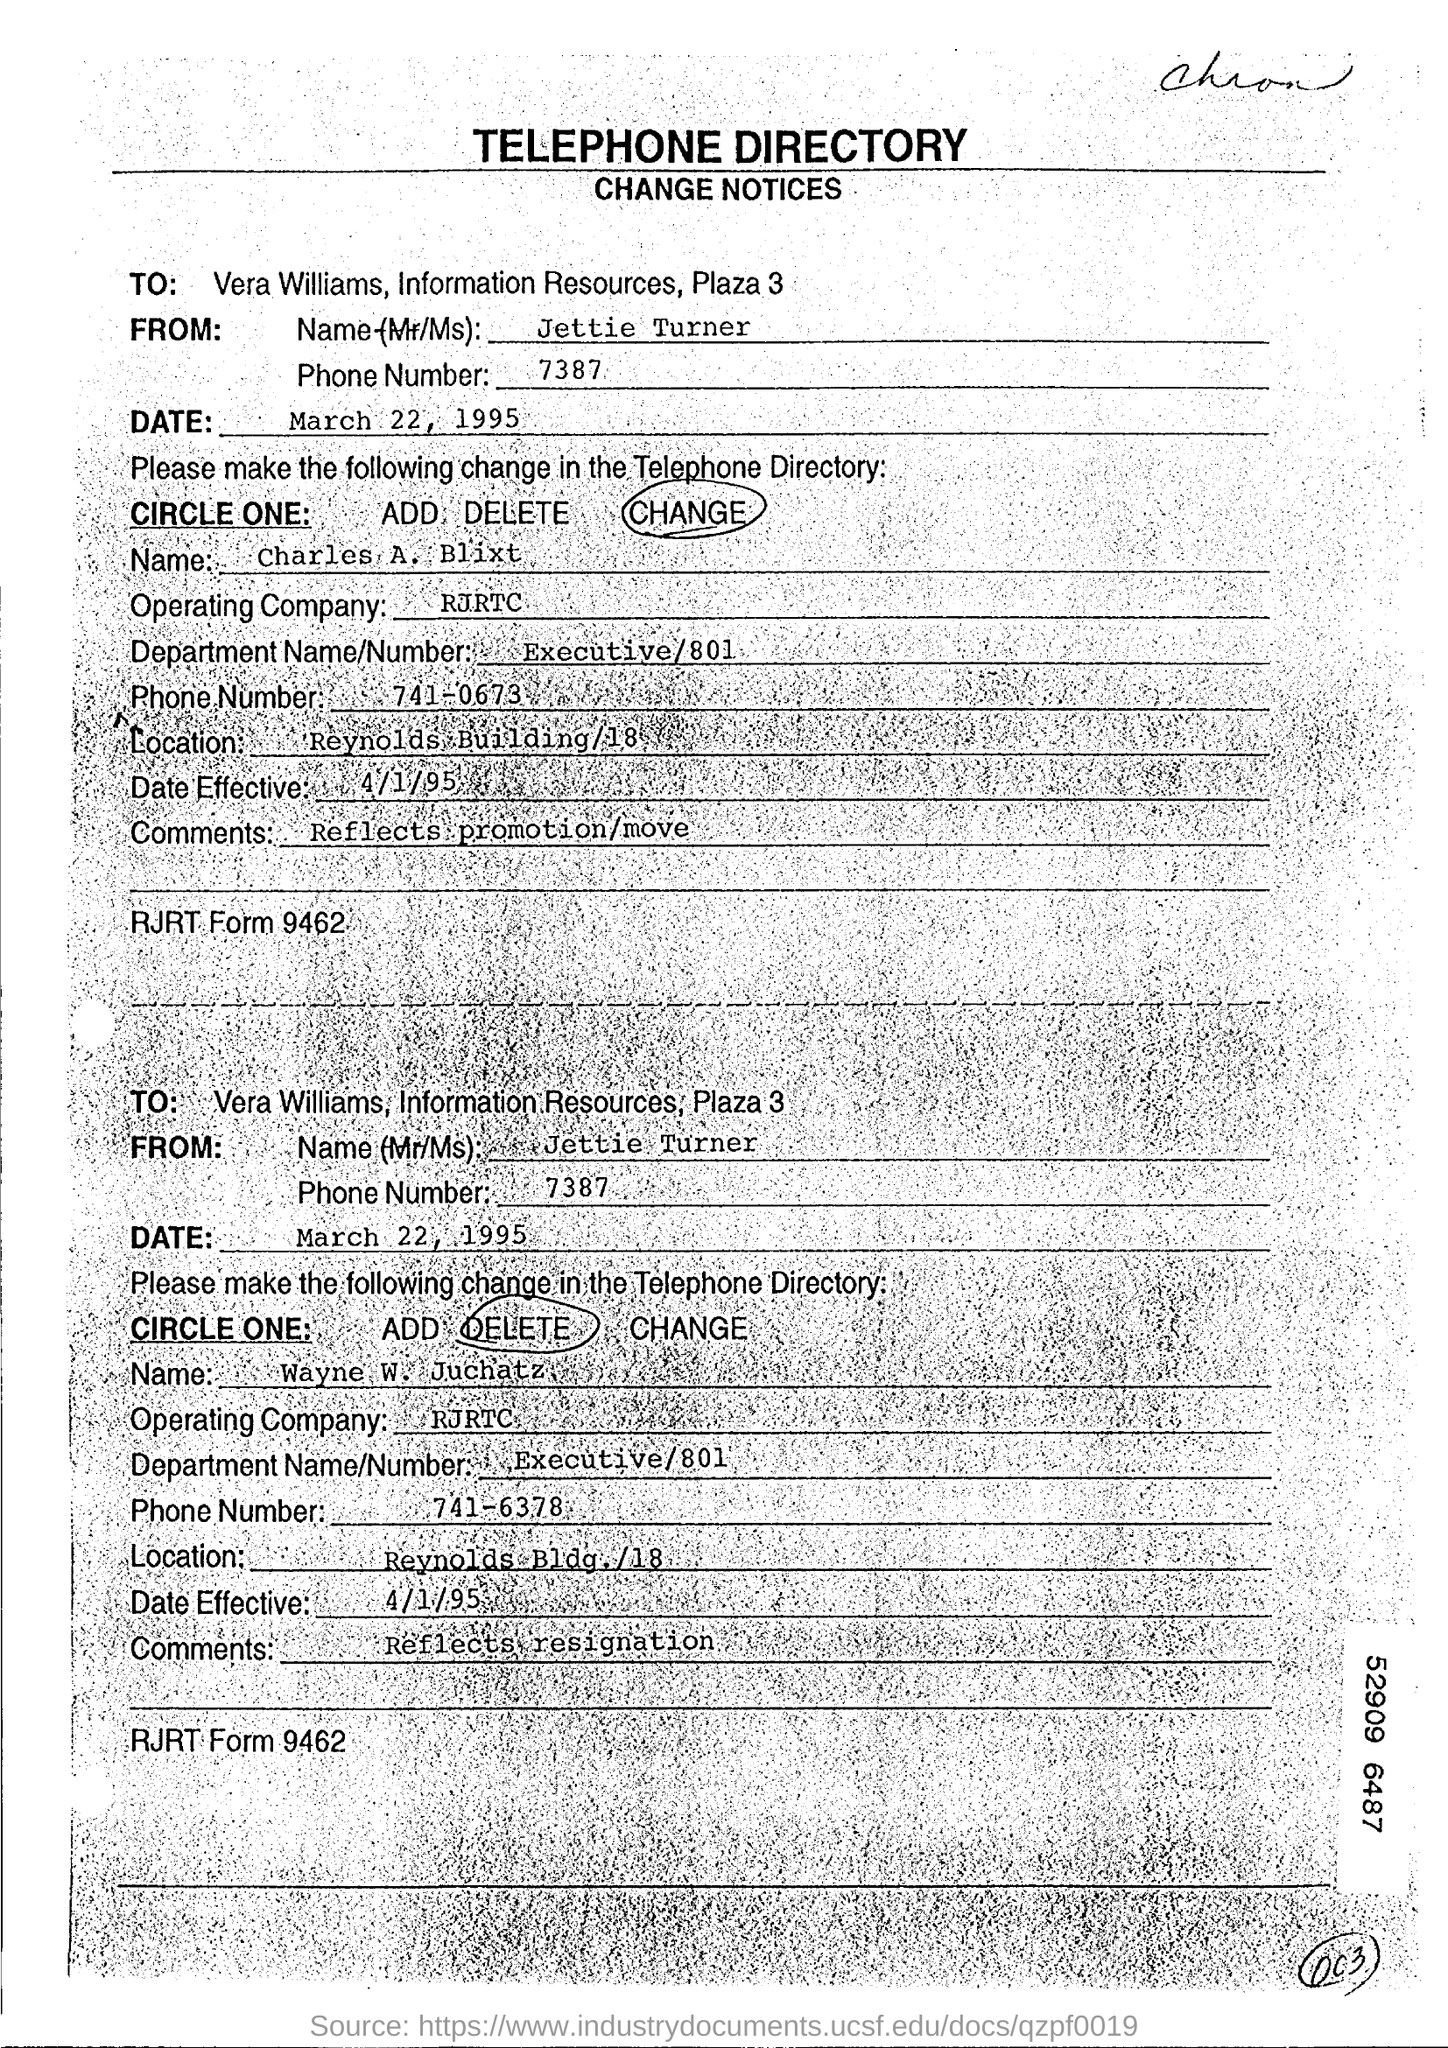Who is it addressed to?
Your answer should be very brief. VERA WILLIAMS, INFORMATION RESOURCES, PLAZA 3. Who is it From?
Your response must be concise. JETTIE TURNER. What is the Phone Number?
Offer a terse response. 7387. What is the Date?
Give a very brief answer. MARCH 22, 1995. What is the Name?
Keep it short and to the point. Charles A. Blixt. Which is the operating Company?
Offer a terse response. RJRTC. What is the Department name/number?
Give a very brief answer. Executive/801. What is the location?
Provide a succinct answer. Reynolds Building/18. When is the date effective?
Your answer should be very brief. 4/1/95. What are the comments?
Provide a short and direct response. REFLECTS PROMOTION/MOVE. 